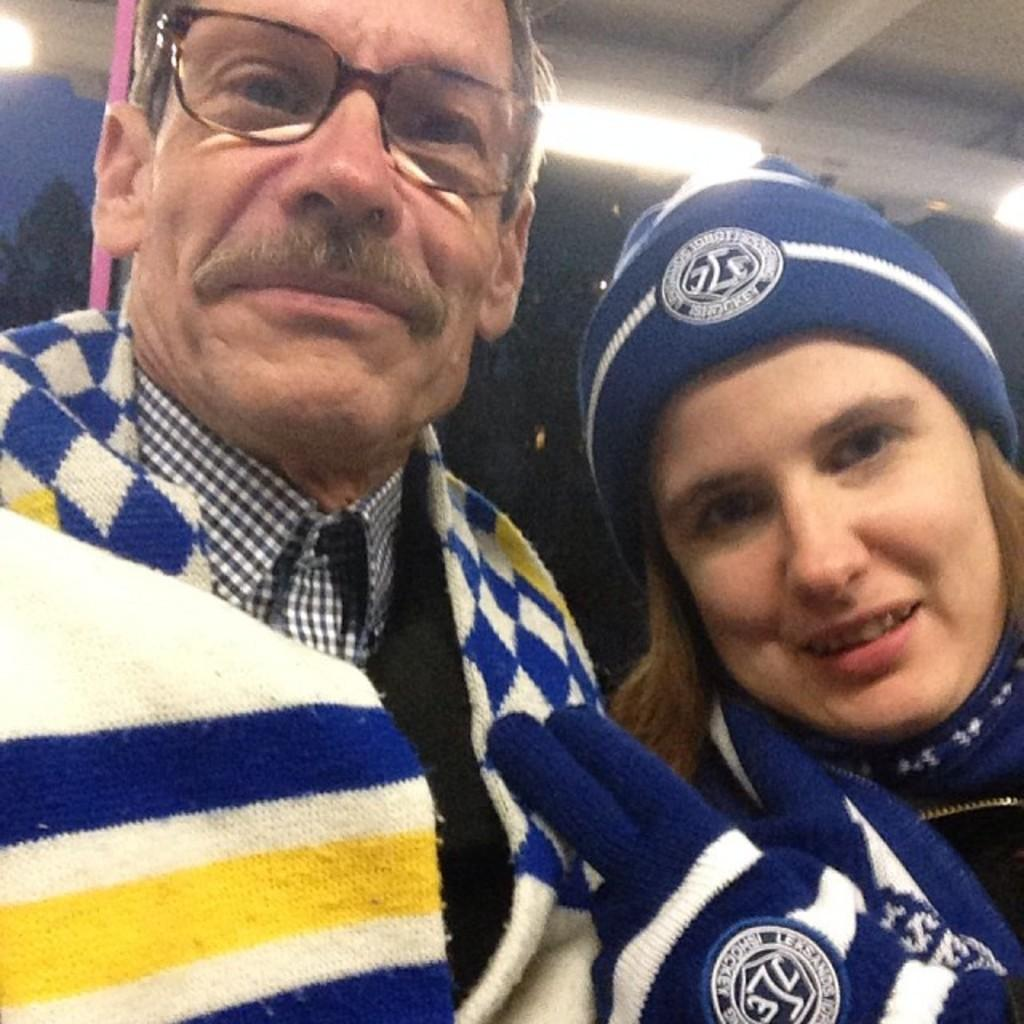Who is present in the image? There is a girl in the image. What object is located in the center of the image? There is a lamp in the center of the image. Are there any other lamps visible in the image? Yes, there are lamps at the top side of the image. How many cows can be seen in the image? There are no cows present in the image. What fact can be learned about the girl from the image? The provided facts do not give any information about the girl's background or personal details, so no specific fact can be learned about her from the image. 